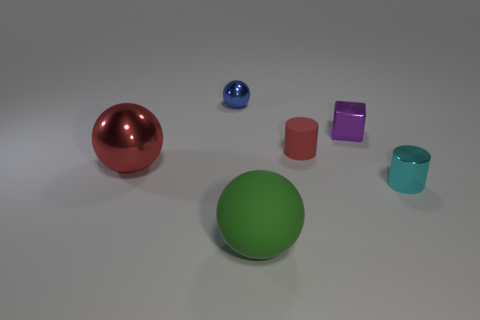Add 4 big red matte things. How many objects exist? 10 Subtract all cylinders. How many objects are left? 4 Subtract all matte things. Subtract all green matte balls. How many objects are left? 3 Add 5 green rubber spheres. How many green rubber spheres are left? 6 Add 1 tiny red metal cylinders. How many tiny red metal cylinders exist? 1 Subtract 0 gray cylinders. How many objects are left? 6 